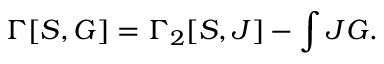<formula> <loc_0><loc_0><loc_500><loc_500>\Gamma [ S , G ] = \Gamma _ { 2 } [ S , J ] - \int J G .</formula> 